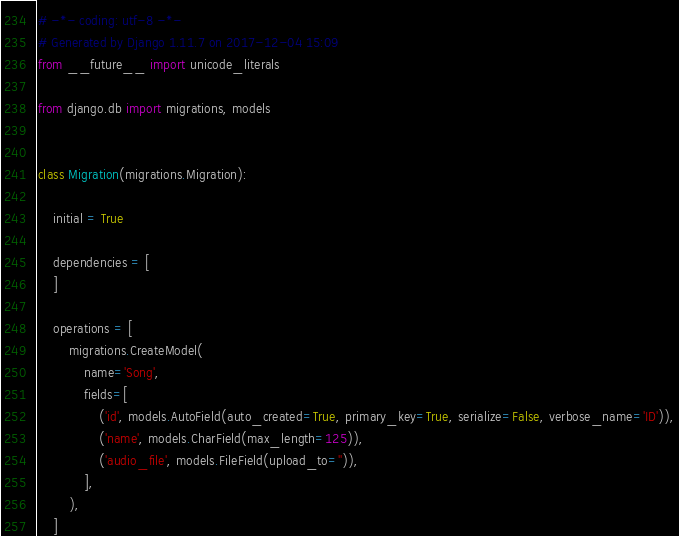Convert code to text. <code><loc_0><loc_0><loc_500><loc_500><_Python_># -*- coding: utf-8 -*-
# Generated by Django 1.11.7 on 2017-12-04 15:09
from __future__ import unicode_literals

from django.db import migrations, models


class Migration(migrations.Migration):

    initial = True

    dependencies = [
    ]

    operations = [
        migrations.CreateModel(
            name='Song',
            fields=[
                ('id', models.AutoField(auto_created=True, primary_key=True, serialize=False, verbose_name='ID')),
                ('name', models.CharField(max_length=125)),
                ('audio_file', models.FileField(upload_to='')),
            ],
        ),
    ]
</code> 